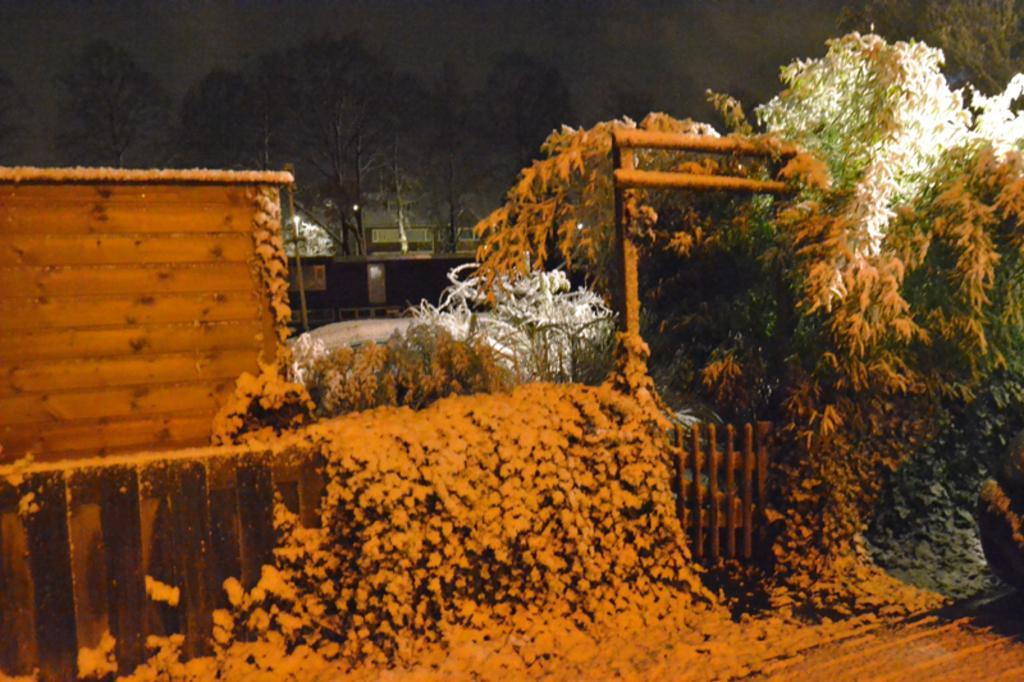How would you summarize this image in a sentence or two? In this image there are trees and some are covered with snow. There is also a fence covered with snow. In the background there is a wall, pole and trees. 